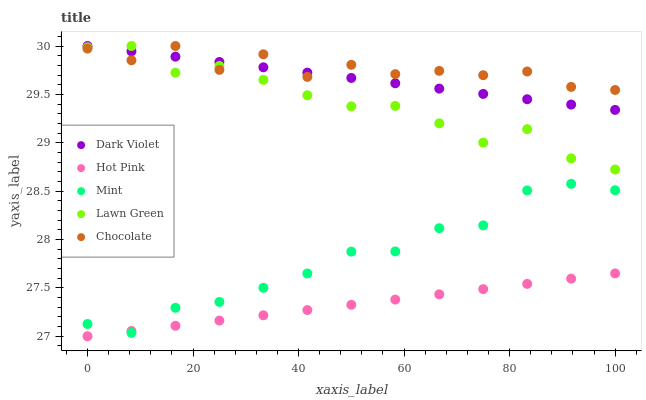Does Hot Pink have the minimum area under the curve?
Answer yes or no. Yes. Does Chocolate have the maximum area under the curve?
Answer yes or no. Yes. Does Mint have the minimum area under the curve?
Answer yes or no. No. Does Mint have the maximum area under the curve?
Answer yes or no. No. Is Hot Pink the smoothest?
Answer yes or no. Yes. Is Chocolate the roughest?
Answer yes or no. Yes. Is Mint the smoothest?
Answer yes or no. No. Is Mint the roughest?
Answer yes or no. No. Does Hot Pink have the lowest value?
Answer yes or no. Yes. Does Mint have the lowest value?
Answer yes or no. No. Does Chocolate have the highest value?
Answer yes or no. Yes. Does Mint have the highest value?
Answer yes or no. No. Is Mint less than Dark Violet?
Answer yes or no. Yes. Is Chocolate greater than Mint?
Answer yes or no. Yes. Does Chocolate intersect Lawn Green?
Answer yes or no. Yes. Is Chocolate less than Lawn Green?
Answer yes or no. No. Is Chocolate greater than Lawn Green?
Answer yes or no. No. Does Mint intersect Dark Violet?
Answer yes or no. No. 